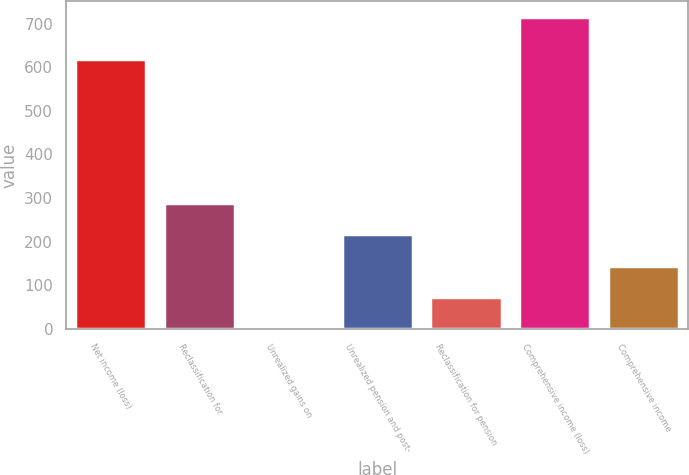Convert chart. <chart><loc_0><loc_0><loc_500><loc_500><bar_chart><fcel>Net income (loss)<fcel>Reclassification for<fcel>Unrealized gains on<fcel>Unrealized pension and post-<fcel>Reclassification for pension<fcel>Comprehensive income (loss)<fcel>Comprehensive income<nl><fcel>617.9<fcel>289.76<fcel>0.2<fcel>217.37<fcel>72.59<fcel>715.2<fcel>144.98<nl></chart> 